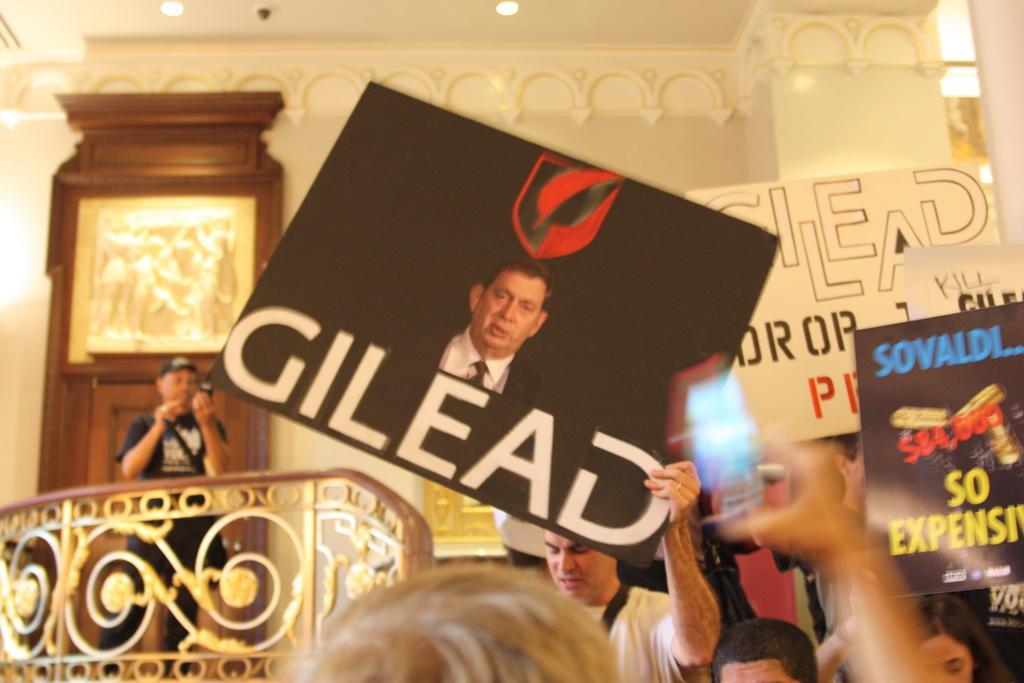In one or two sentences, can you explain what this image depicts? The picture consists of placards and people. On the left there is a person holding camera. On the left there are railing and a door. At the top there are lights to the ceiling. 